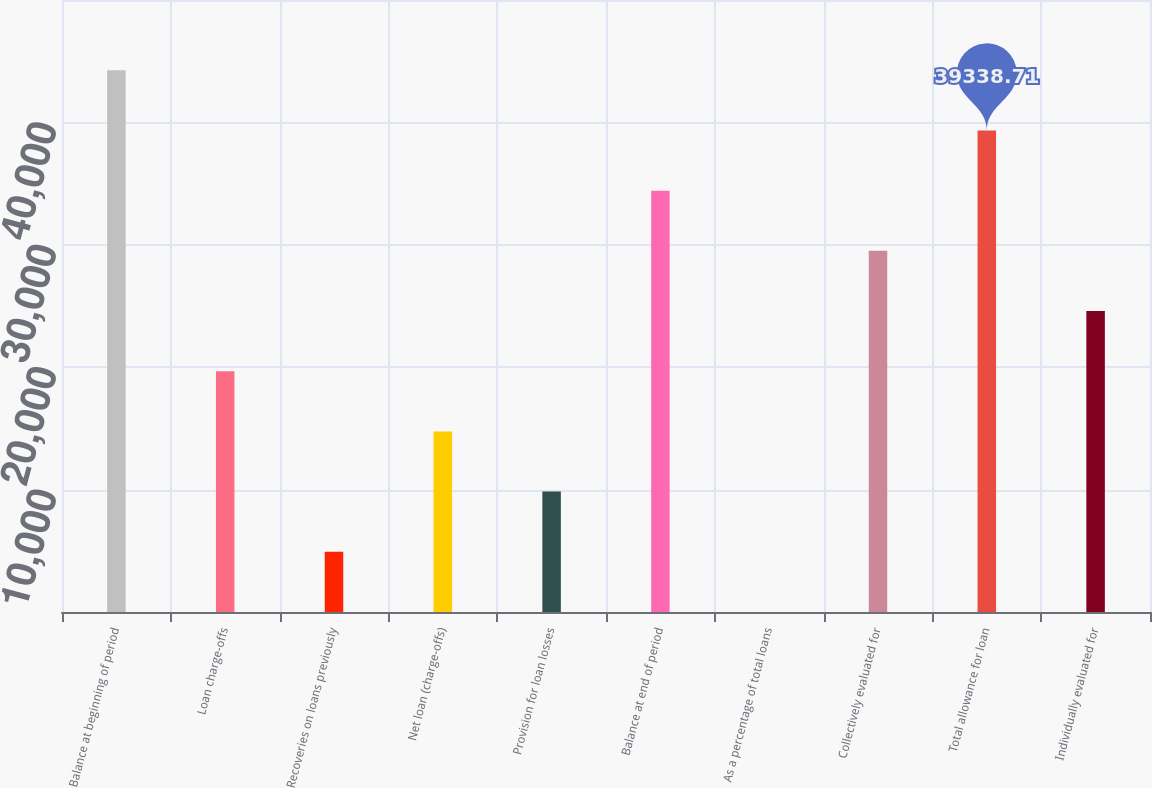<chart> <loc_0><loc_0><loc_500><loc_500><bar_chart><fcel>Balance at beginning of period<fcel>Loan charge-offs<fcel>Recoveries on loans previously<fcel>Net loan (charge-offs)<fcel>Provision for loan losses<fcel>Balance at end of period<fcel>As a percentage of total loans<fcel>Collectively evaluated for<fcel>Total allowance for loan<fcel>Individually evaluated for<nl><fcel>44255.9<fcel>19670.1<fcel>4918.61<fcel>14752.9<fcel>9835.76<fcel>34421.6<fcel>1.45<fcel>29504.4<fcel>39338.7<fcel>24587.2<nl></chart> 